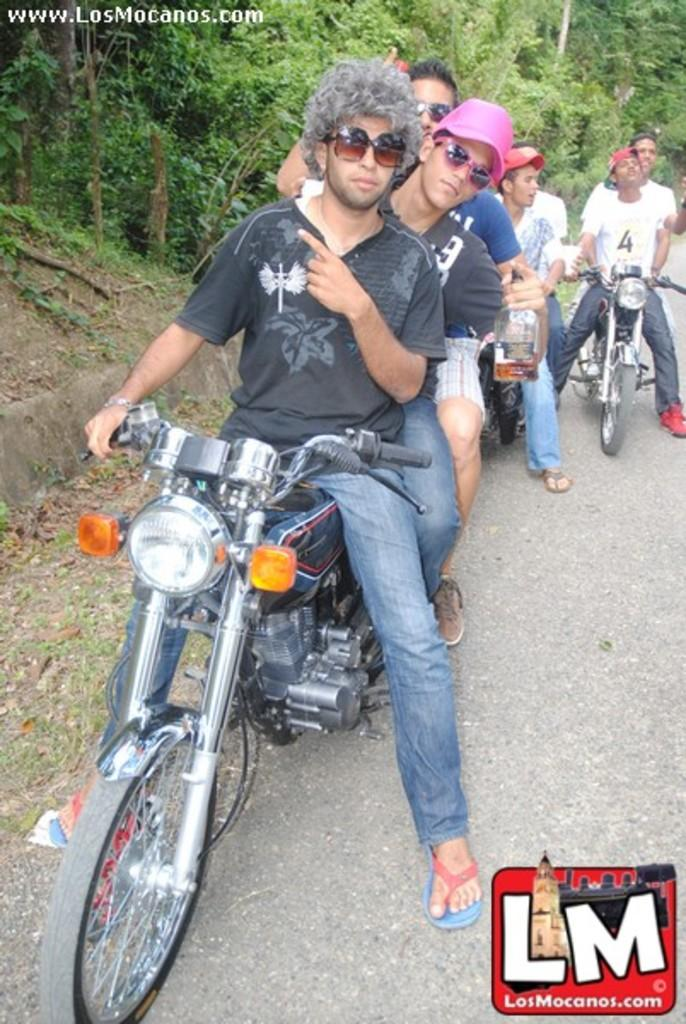What are the people in the image doing? The people in the image are sitting on motorbikes. Can you describe the clothing of one of the men? One man is wearing a black t-shirt and goggles. What is another man holding in the image? Another man is holding a bottle. What can be seen in the distance behind the motorbikes? There are trees visible in the background. How does the wealth of the people in the image contribute to their ability to ride motorbikes? There is no information about the wealth of the people in the image, and their ability to ride motorbikes is not related to their financial status. 